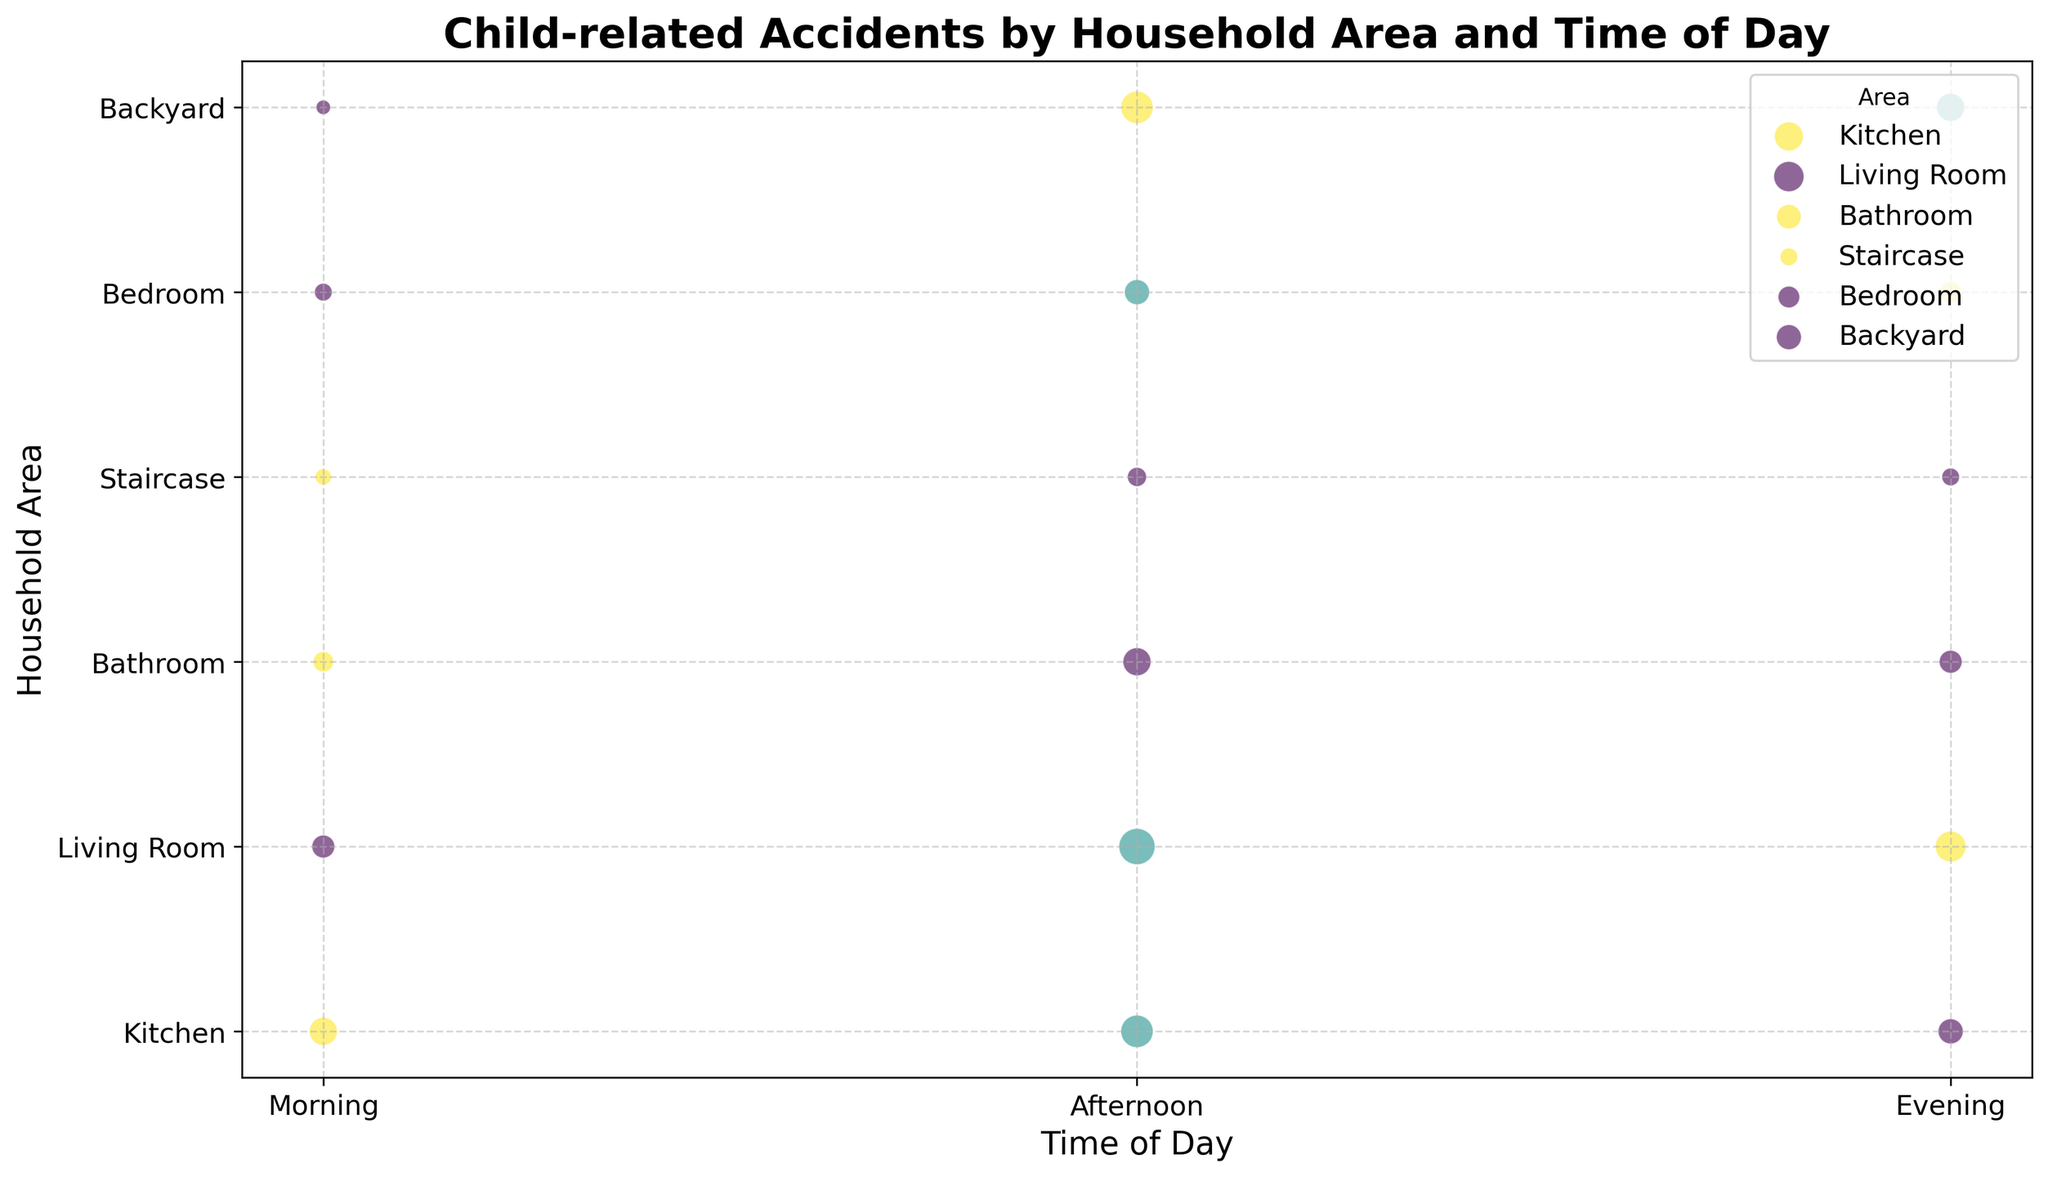Which household area has the highest number of accidents in the afternoon? Look at the bubble size in the afternoon category for all areas. The largest bubble is in the Living Room.
Answer: Living Room What is the total number of accidents in the Kitchen throughout the day? Sum the number of accidents in the Kitchen for morning, afternoon, and evening: 15 (morning) + 20 (afternoon) + 12 (evening) = 47.
Answer: 47 Which time of day generally has the highest number of accidents in the Backyard? Compare the bubble sizes for morning, afternoon, and evening in the Backyard. The largest bubble is in the afternoon.
Answer: Afternoon Which household area has the highest severity of accidents in the morning? Compare the color intensity in the morning for all areas. The Staircase has the highest severity with the most intense color.
Answer: Staircase Are the number of accidents in the Living Room in the evening higher, lower, or equal to those in the Bedroom in the afternoon? Compare the bubble size for Living Room in the evening (18) and Bedroom in the afternoon (12). 18 is greater than 12.
Answer: Higher What is the average severity of accidents in the Bathroom throughout the day? Calculate the average of the severity values in the Bathroom for morning (9), afternoon (8), and evening (8). Average = (9 + 8 + 8) / 3 = 25 / 3 ≈ 8.33.
Answer: 8.33 Which time of day has the least number of accidents in all areas combined? Sum the number of accidents for each time of day: 
Morning = (15+10+8+5+6+4) = 48, 
Afternoon = (20+25+15+7+12+20) = 99, 
Evening = (12+18+10+6+9+15) = 70. 
Morning has the least total number of accidents with 48.
Answer: Morning Is the number of accidents in the Backyard higher in the morning or evening? Compare the bubble sizes for the Backyard in the morning (4) and evening (15). The bubble in the evening is larger, indicating more accidents.
Answer: Evening Which household area shows a consistent severity level of accidents throughout the day? Examine color intensities for each area across times of day. The Bathroom shows consistent severity levels (all around 8).
Answer: Bathroom 